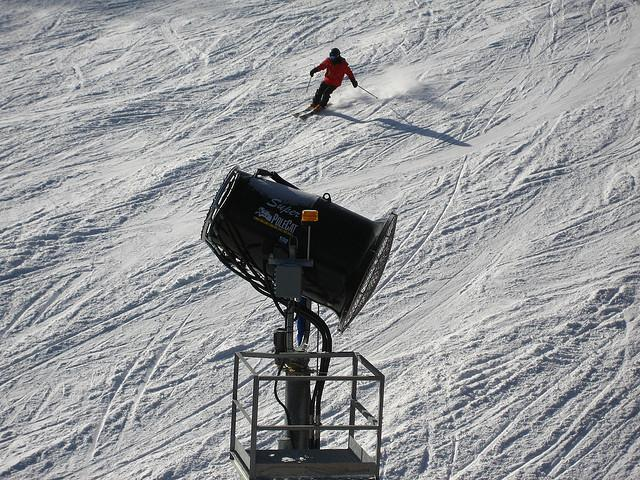What is the person in the jacket holding? Please explain your reasoning. skis. The person has skis. 